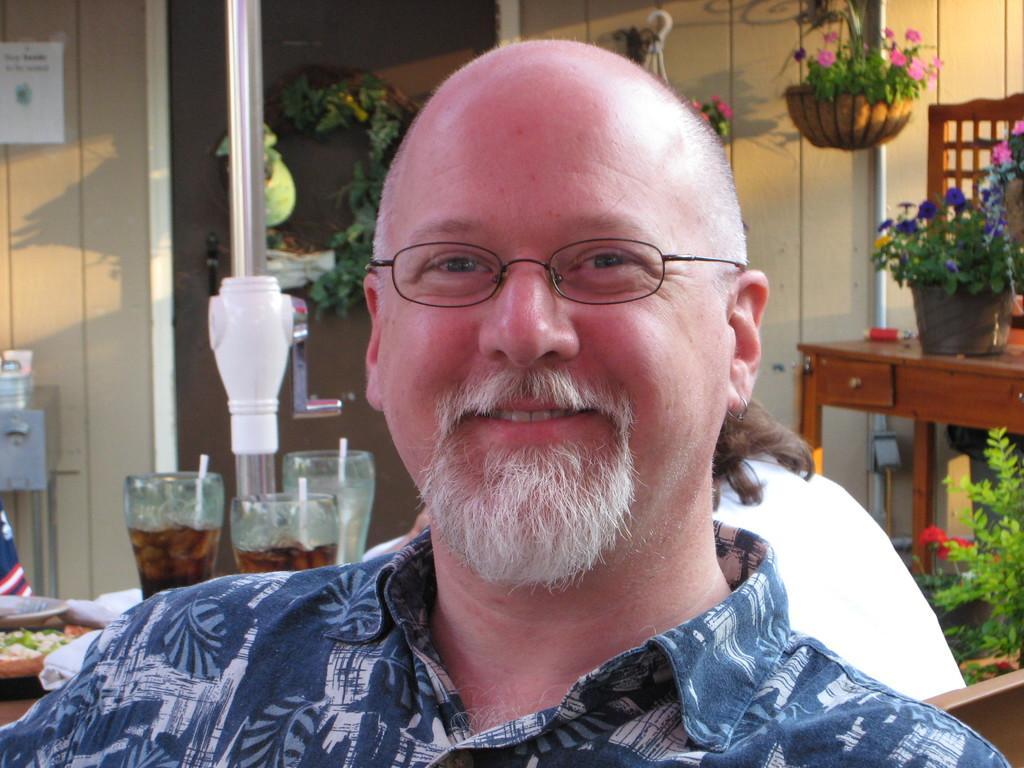How would you summarize this image in a sentence or two? In the picture we can see man wearing blue color dress and spectacles sitting and in the background there are two persons sitting on chairs around table on which there are some glasses, food item, there are some plants which are flower pots are hanged and some are placed on table and there is a wall. 